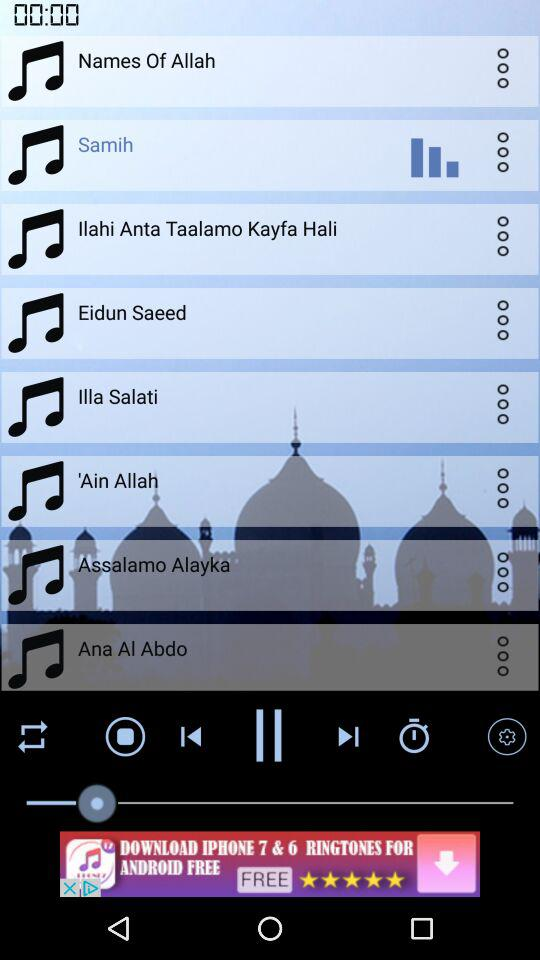What is the displayed duration? The displayed duration is 0 minutes and 0 seconds. 